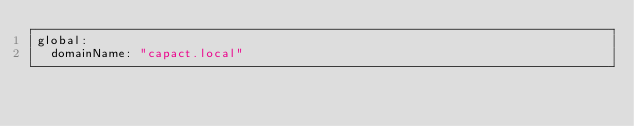Convert code to text. <code><loc_0><loc_0><loc_500><loc_500><_YAML_>global:
  domainName: "capact.local"
</code> 